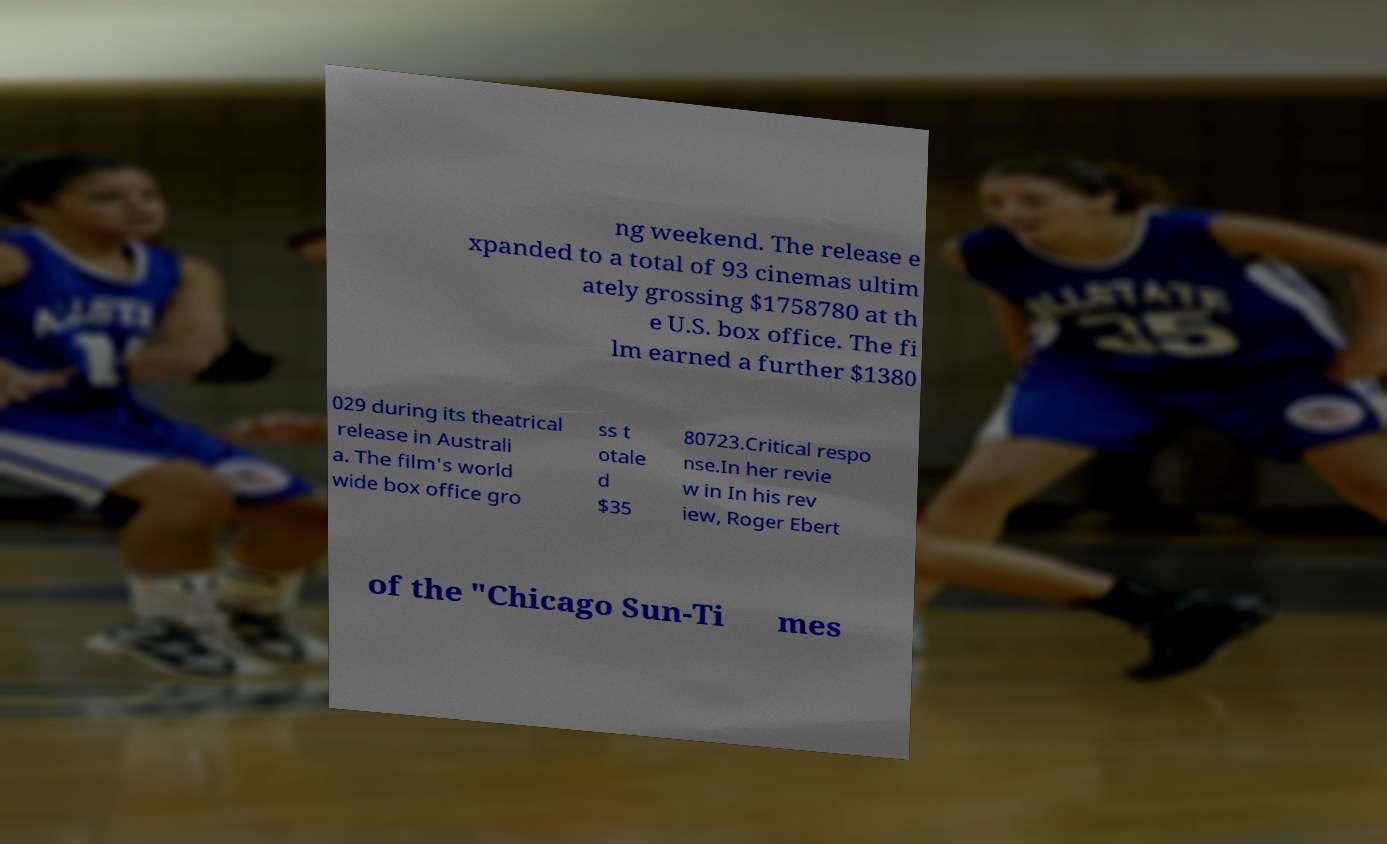For documentation purposes, I need the text within this image transcribed. Could you provide that? ng weekend. The release e xpanded to a total of 93 cinemas ultim ately grossing $1758780 at th e U.S. box office. The fi lm earned a further $1380 029 during its theatrical release in Australi a. The film's world wide box office gro ss t otale d $35 80723.Critical respo nse.In her revie w in In his rev iew, Roger Ebert of the "Chicago Sun-Ti mes 